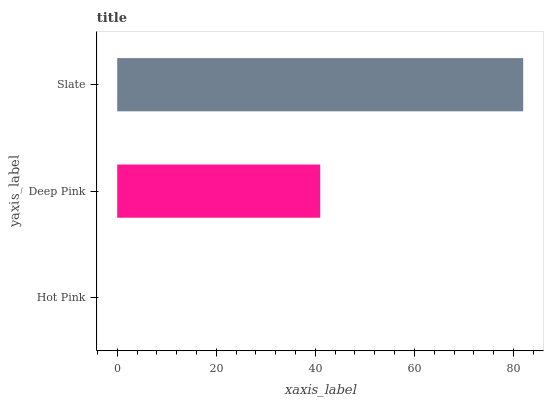Is Hot Pink the minimum?
Answer yes or no. Yes. Is Slate the maximum?
Answer yes or no. Yes. Is Deep Pink the minimum?
Answer yes or no. No. Is Deep Pink the maximum?
Answer yes or no. No. Is Deep Pink greater than Hot Pink?
Answer yes or no. Yes. Is Hot Pink less than Deep Pink?
Answer yes or no. Yes. Is Hot Pink greater than Deep Pink?
Answer yes or no. No. Is Deep Pink less than Hot Pink?
Answer yes or no. No. Is Deep Pink the high median?
Answer yes or no. Yes. Is Deep Pink the low median?
Answer yes or no. Yes. Is Hot Pink the high median?
Answer yes or no. No. Is Slate the low median?
Answer yes or no. No. 